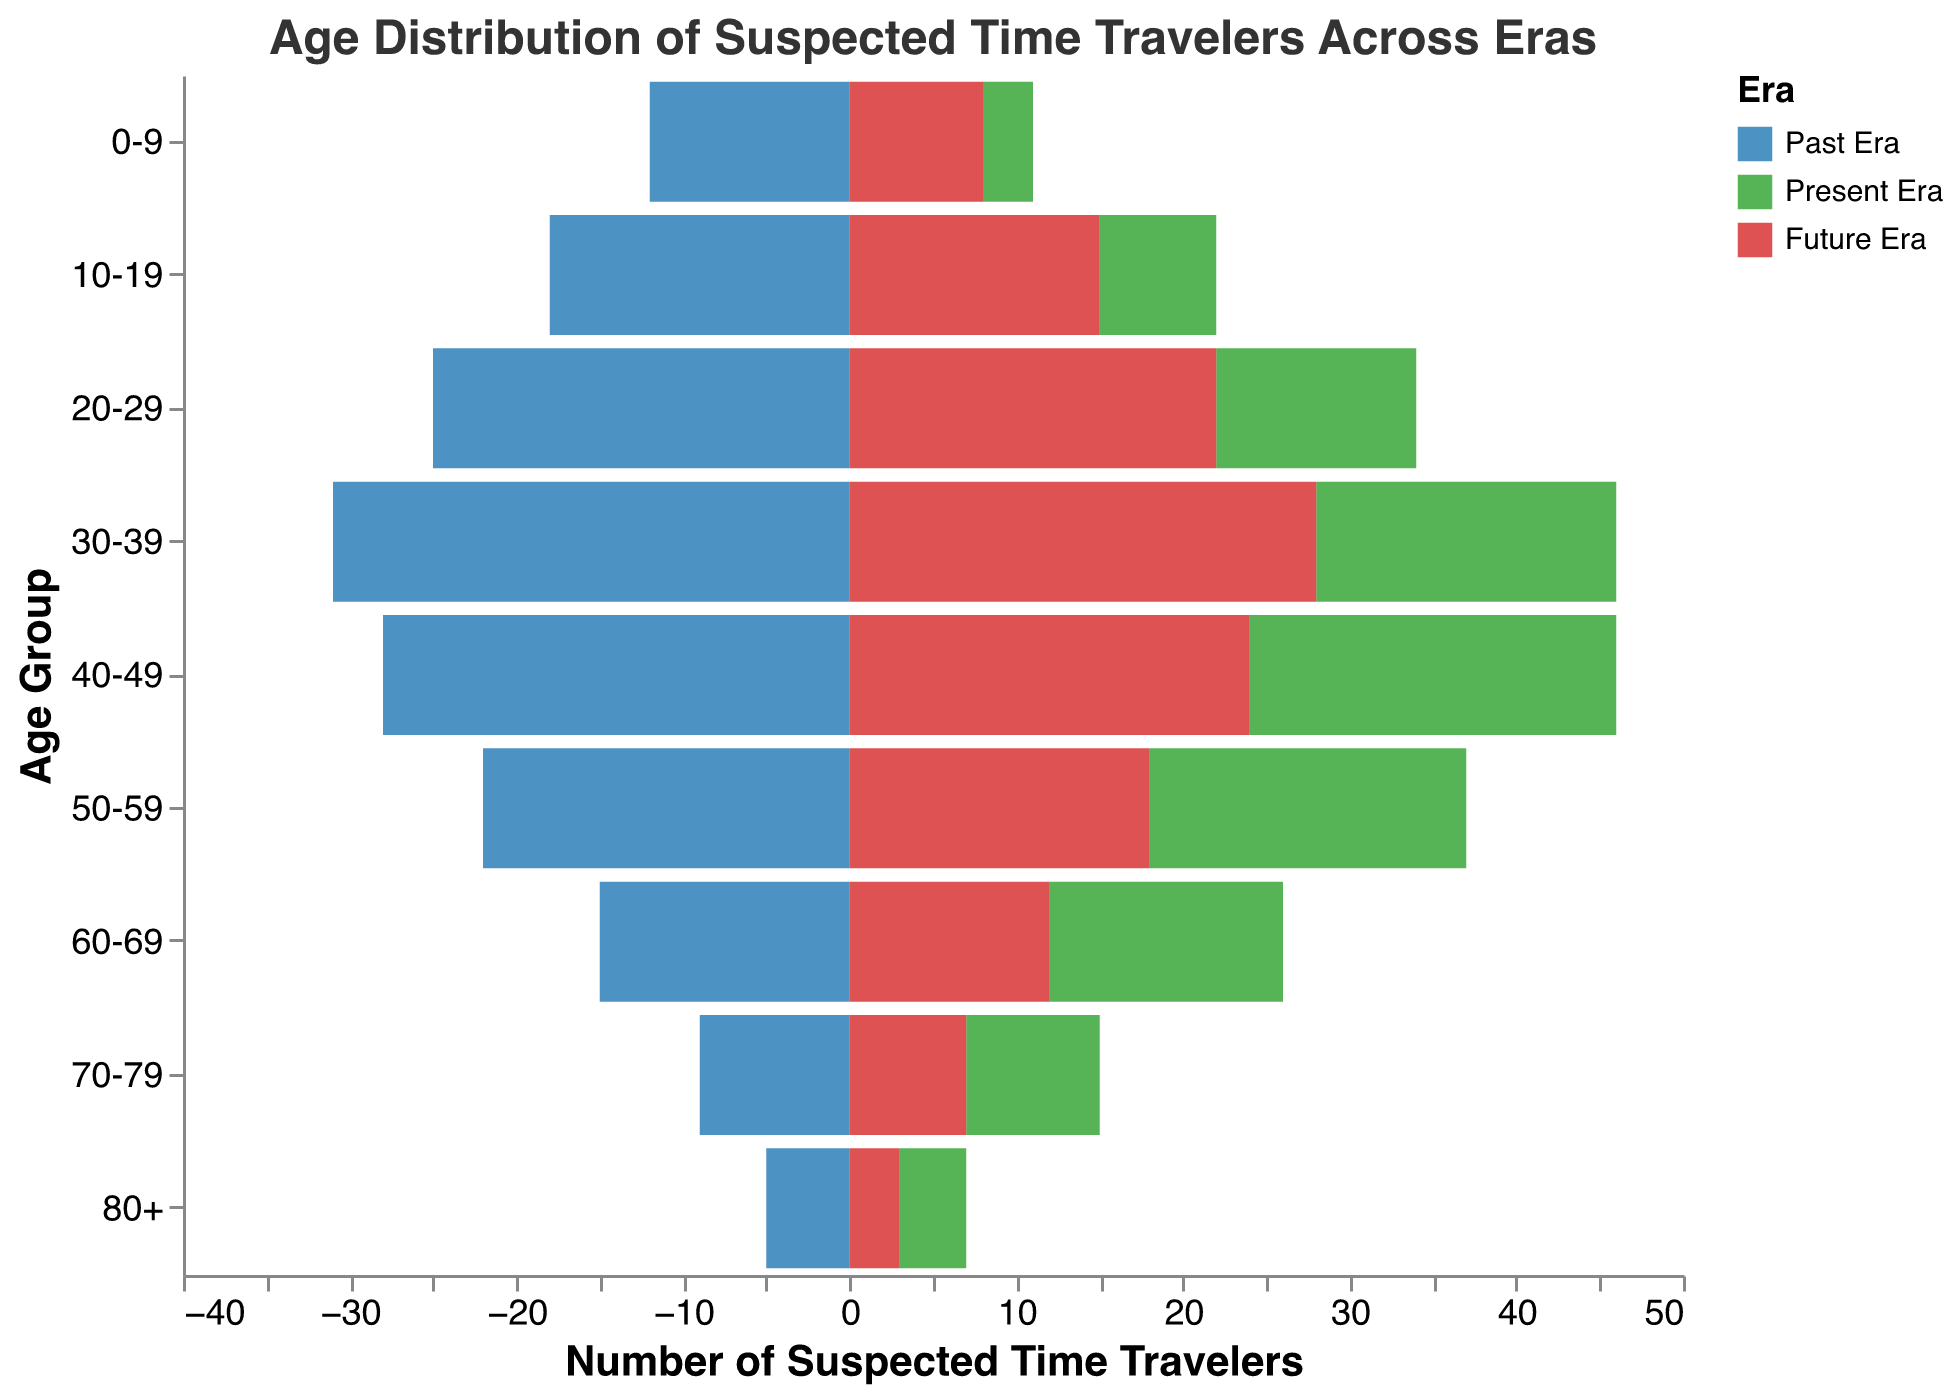What is the title of the figure? The title of the figure is usually displayed at the top, and it succinctly describes the subject of the data being visualized. In this case, it is clearly stated.
Answer: Age Distribution of Suspected Time Travelers Across Eras What is the number of suspected time travelers aged 30-39 from the Future Era? To answer this, locate the bar for the age group 30-39. The Future Era data is represented by the red-colored bar, which indicates the number.
Answer: 28 Which age group has the highest number of suspected time travelers in the Past Era? Look at the blue bars, which represent the Past Era. Find the bar that extends the furthest to the left. This will indicate the highest number.
Answer: 30-39 Compare the number of suspected time travelers aged 40-49 between the Past and Present Eras. Which era has a higher number? Identify the bars corresponding to the 40-49 age group. The Past Era is represented by blue and the Present Era by green. Compare the lengths of the bars to determine which is higher.
Answer: Past Era What is the total number of suspected time travelers aged 50-59 across all eras? Sum the numbers from all three eras for the age group 50-59: Past Era (22) + Present Era (19) + Future Era (18). This involves a simple addition of these numbers.
Answer: 59 How does the distribution of suspected time travelers change from the 20-29 age group to the 60-69 age group in the Past Era? Compare the blue bars' lengths for the specified age groups: 20-29 (25), 30-39 (31), 40-49 (28), 50-59 (22), and 60-69 (15). Describe how they increase, peak, and then decrease.
Answer: peaks at 30-39, then decreases Which age group from the Present Era has the smallest number of suspected time travelers? Look for the shortest green bar, which represents the data for the Present Era. This will identify the age group with the minimum value.
Answer: 0-9 Calculate the average number of suspected time travelers aged 0-9 across all eras. To find the average, add the numbers from all three eras for the 0-9 age group: Past Era (12) + Present Era (3) + Future Era (8), then divide by 3. This involves basic arithmetic operations.
Answer: 7.67 What is the difference in the number of suspected time travelers aged 10-19 between the Past and Future Eras? Subtract the number in the Future Era (15, red bar) from the number in the Past Era (18, blue bar) for the age group 10-19. This involves a simple subtraction.
Answer: 3 